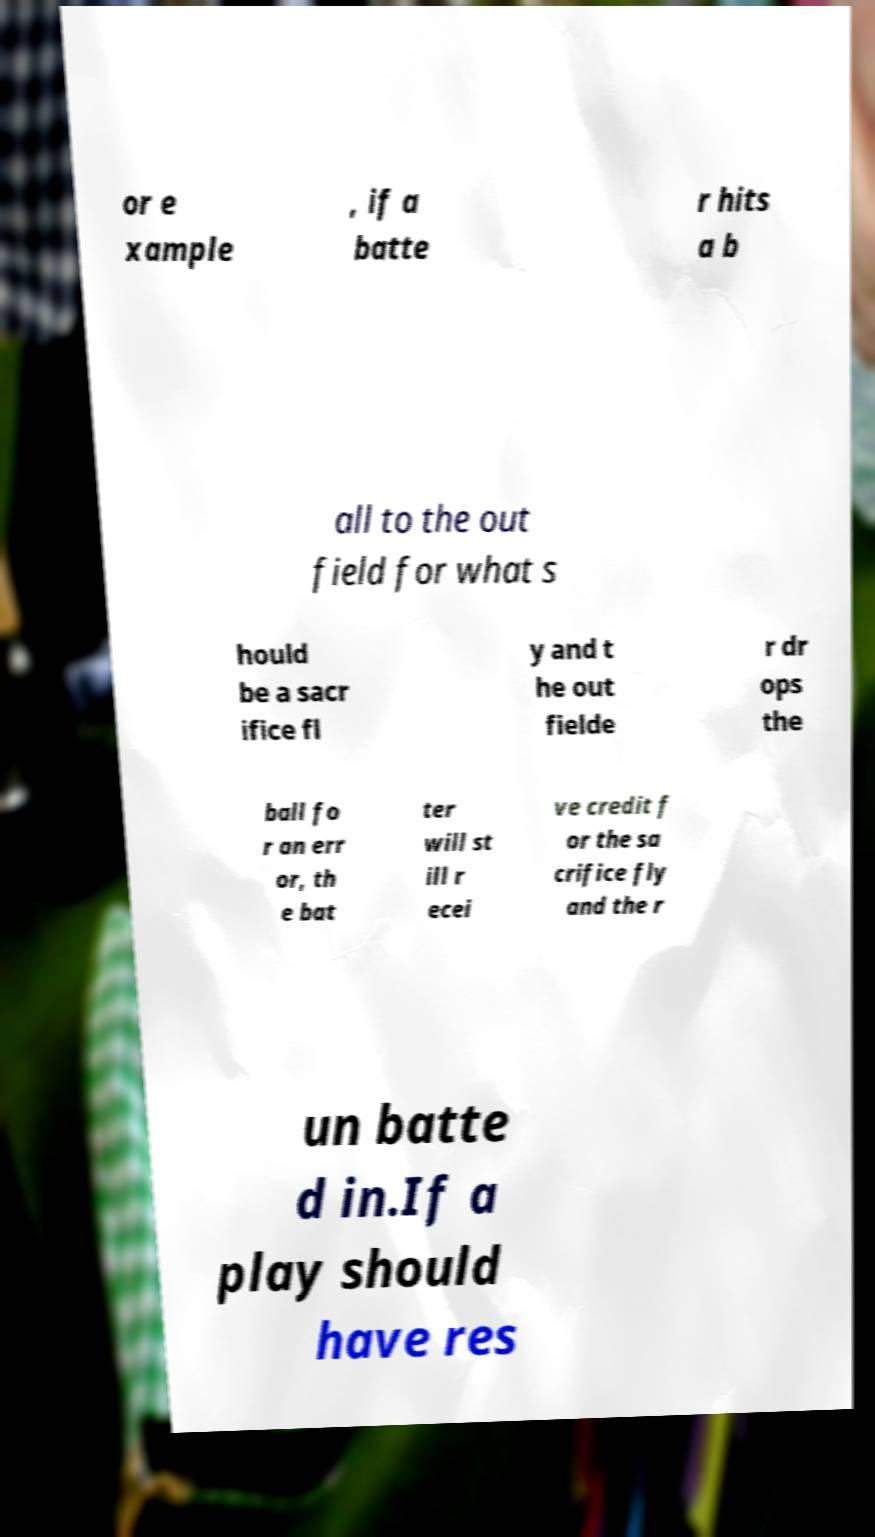I need the written content from this picture converted into text. Can you do that? or e xample , if a batte r hits a b all to the out field for what s hould be a sacr ifice fl y and t he out fielde r dr ops the ball fo r an err or, th e bat ter will st ill r ecei ve credit f or the sa crifice fly and the r un batte d in.If a play should have res 